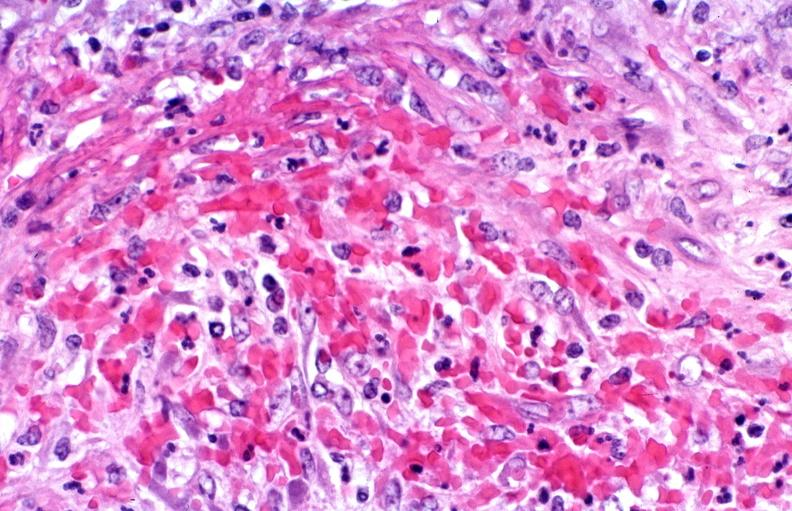what is present?
Answer the question using a single word or phrase. Cardiovascular 